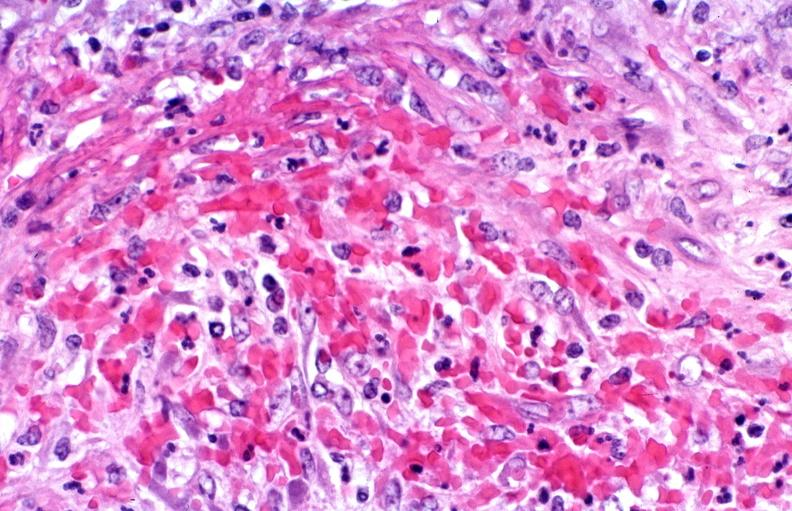what is present?
Answer the question using a single word or phrase. Cardiovascular 